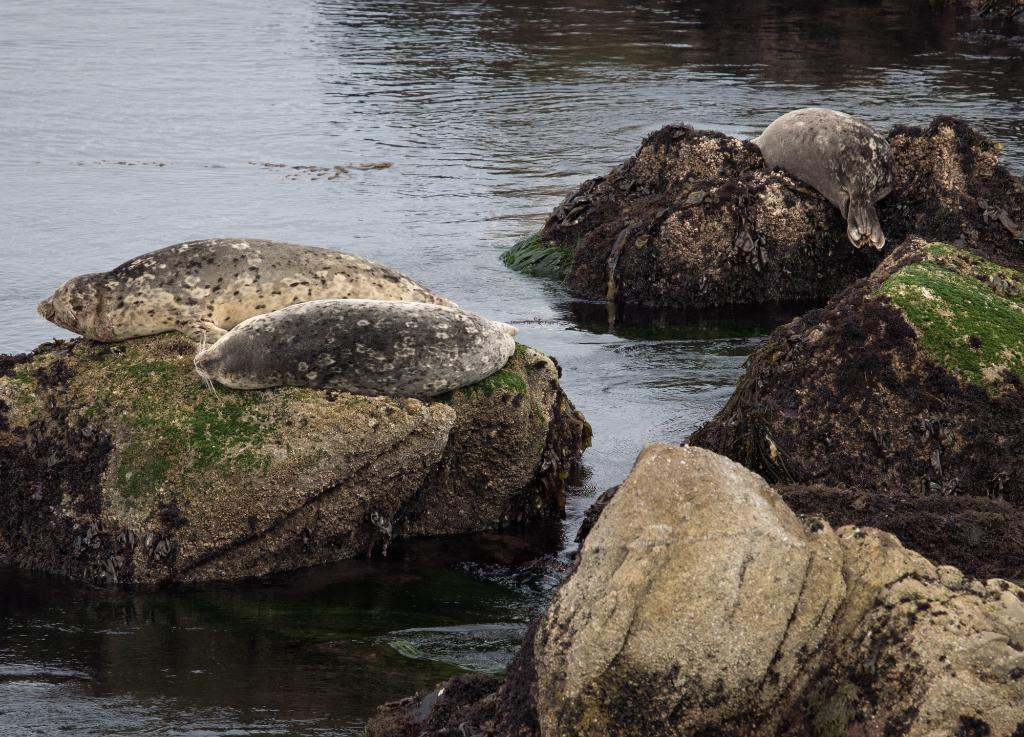What type of natural feature is present in the image? There is a river in the image. What can be seen at the bottom of the river? Big stones are visible at the bottom of the image. What time of day is it during the voyage in the image? There is no indication of a voyage or a specific time of day in the image; it simply shows a river with big stones at the bottom. 